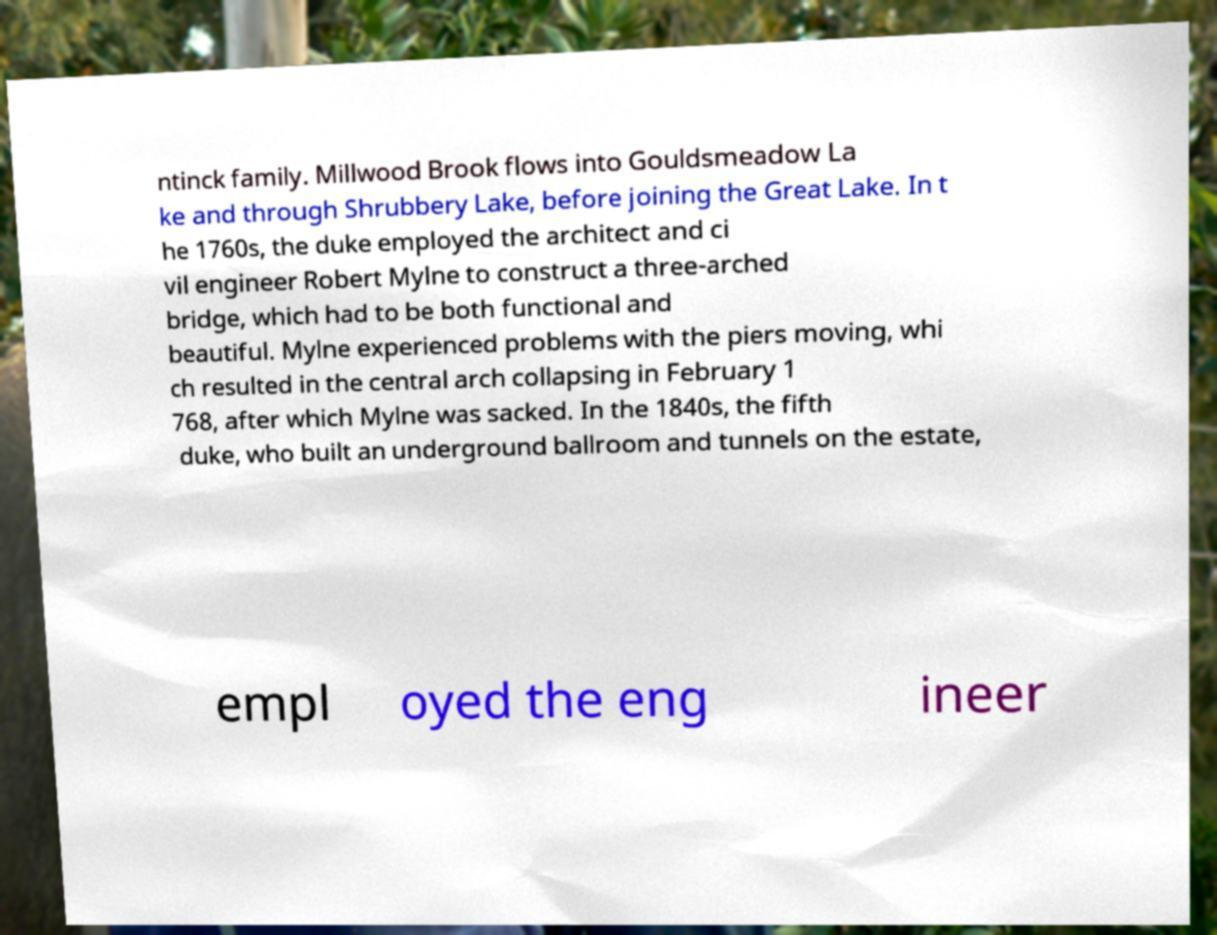There's text embedded in this image that I need extracted. Can you transcribe it verbatim? ntinck family. Millwood Brook flows into Gouldsmeadow La ke and through Shrubbery Lake, before joining the Great Lake. In t he 1760s, the duke employed the architect and ci vil engineer Robert Mylne to construct a three-arched bridge, which had to be both functional and beautiful. Mylne experienced problems with the piers moving, whi ch resulted in the central arch collapsing in February 1 768, after which Mylne was sacked. In the 1840s, the fifth duke, who built an underground ballroom and tunnels on the estate, empl oyed the eng ineer 